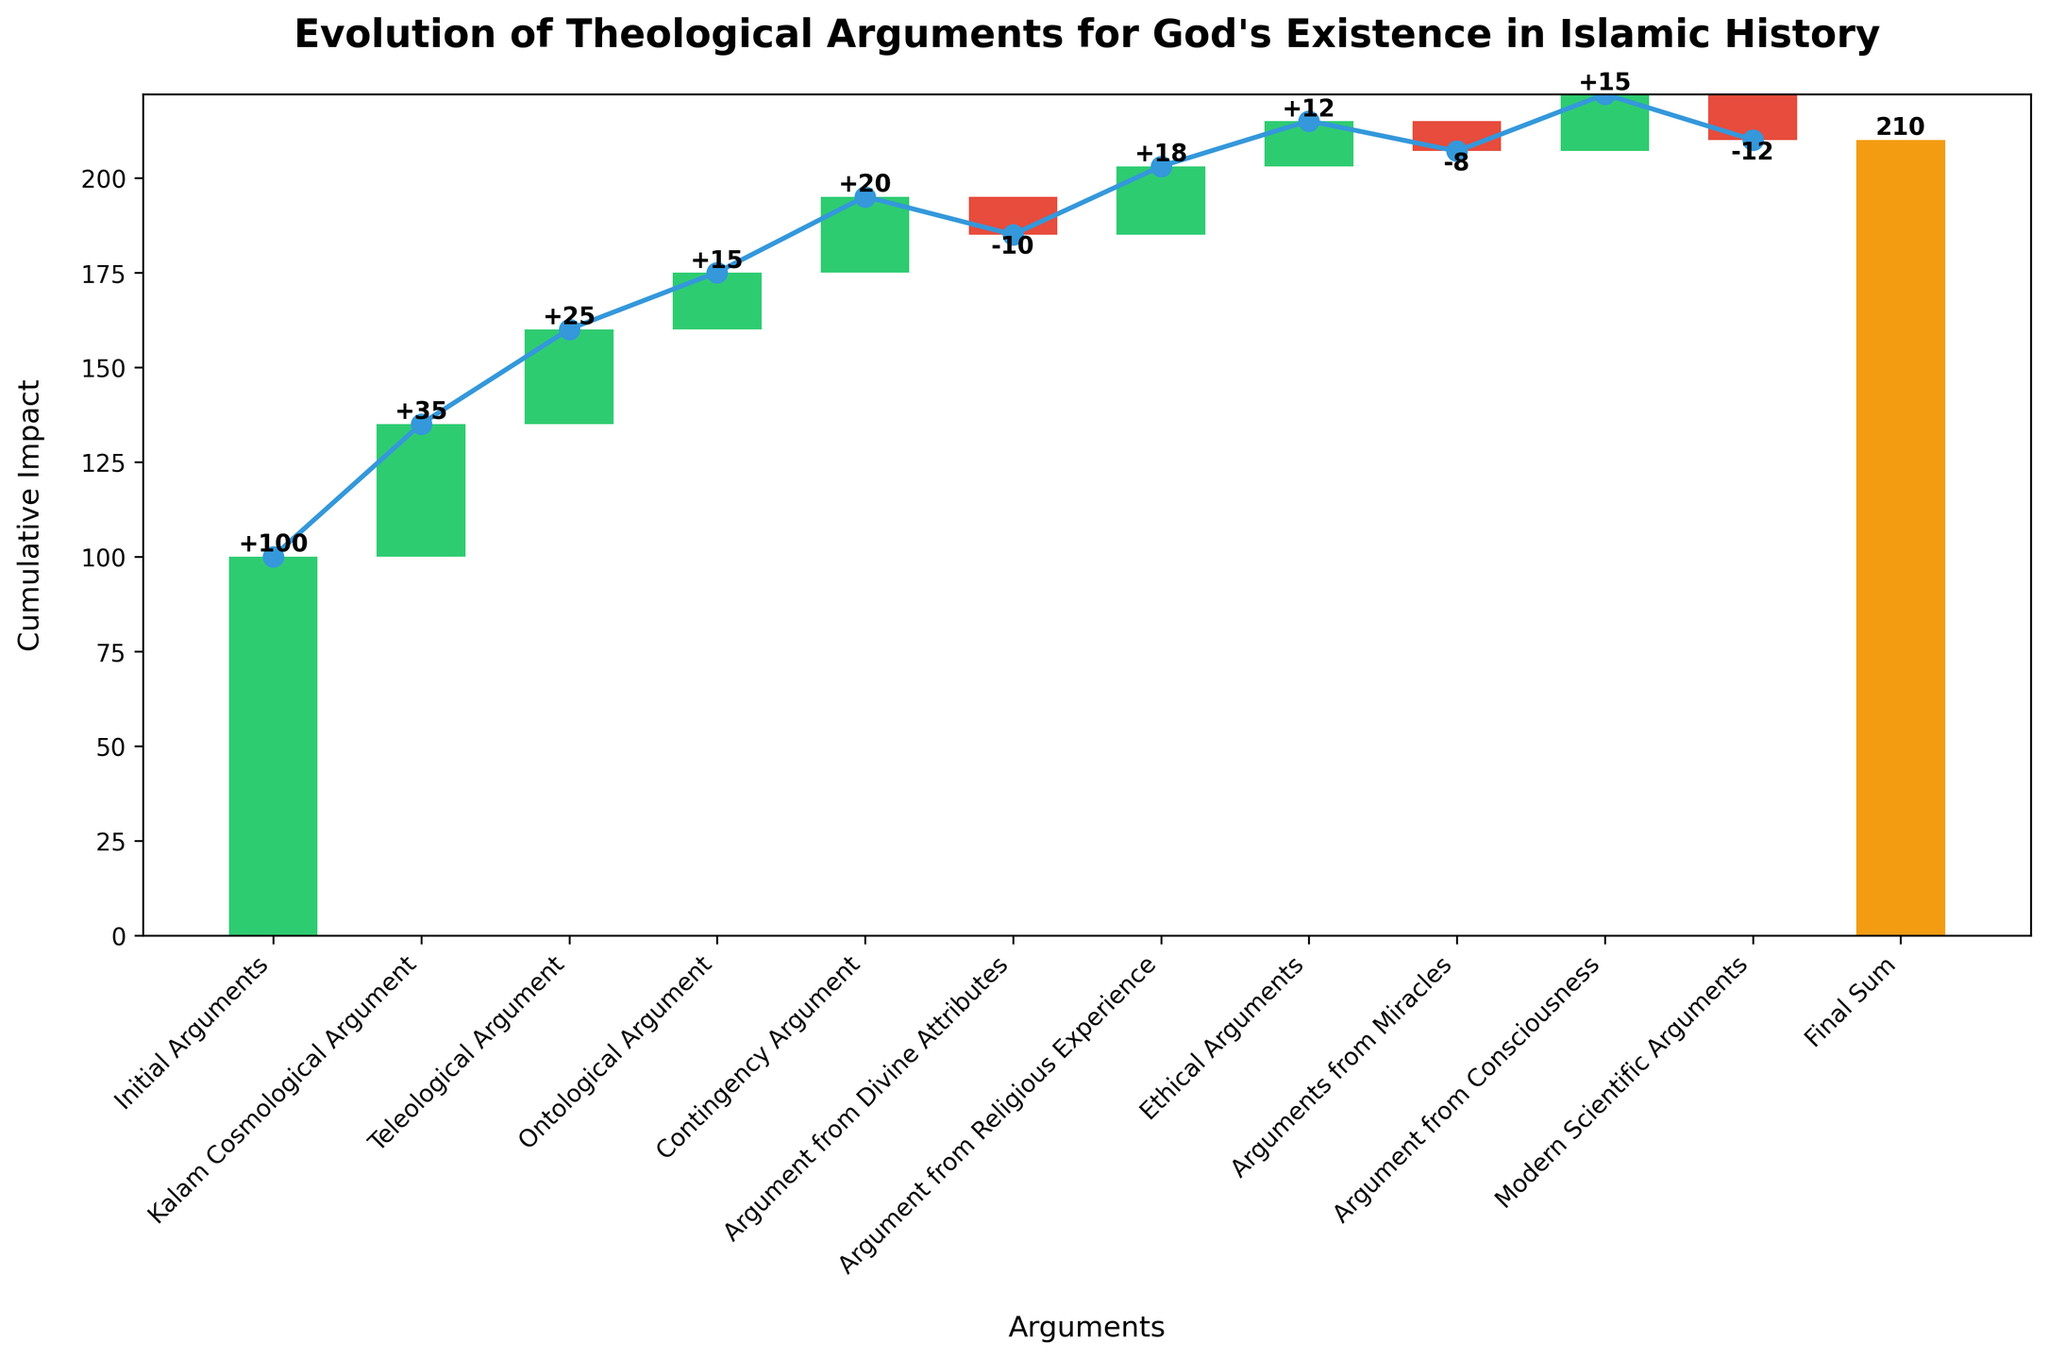What is the title of the chart? The title is written at the top of the chart and describes what the figure is about.
Answer: Evolution of Theological Arguments for God's Existence in Islamic History How many categories are listed in the chart? Count the number of distinct arguments and the final sum mentioned on the x-axis.
Answer: 11 What are the arguments with a negative value? Identify the bars that are colored differently (red in this case) which indicate negative values. These are "Argument from Divine Attributes," "Arguments from Miracles," and "Modern Scientific Arguments".
Answer: Three arguments What is the cumulative impact after the introduction of the Teleological Argument? Calculate the cumulative value from the start through the Teleological Argument by summing the initial value and the values up to this point. The Initial Arguments start at 100, the Kalam Cosmological Argument adds 35, and the Teleological Argument adds 25: 100 + 35 + 25 = 160
Answer: 160 Which arguments had the highest positive impact on the cumulative score? Compare the values provided for each argument to determine which one has the largest positive number. The argument with the highest positive impact is the Kalam Cosmological Argument with a value of +35.
Answer: Kalam Cosmological Argument What is the difference in impact between the Argument from Religious Experience and Arguments from Miracles? Calculate the difference by subtracting the value of Arguments from Miracles from the value of the Argument from Religious Experience: 18 - (-8) = 18 + 8 = 26
Answer: 26 What is the cumulative value just before the Argument from Consciousness? Calculate the cumulative sum up to but not including the Argument from Consciousness. Sum the Initial Arguments to the value just before it: 100 + 35 + 25 + 15 + 20 - 10 + 18 + 12 - 8 = 207
Answer: 207 What is the final cumulative sum shown in the chart? The final cumulative sum is highlighted as the last bar on the chart labeled 'Final Sum'.
Answer: 210 How many arguments had a positive impact? Count the number of bars with positive values, which are indicated by a specific color (green in this case).
Answer: 7 Which argument had the smallest impact in either direction (positive or negative)? Identify the argument with the smallest absolute value. The smallest impact in either direction is the Arguments from Miracles with a value of -8.
Answer: Arguments from Miracles 